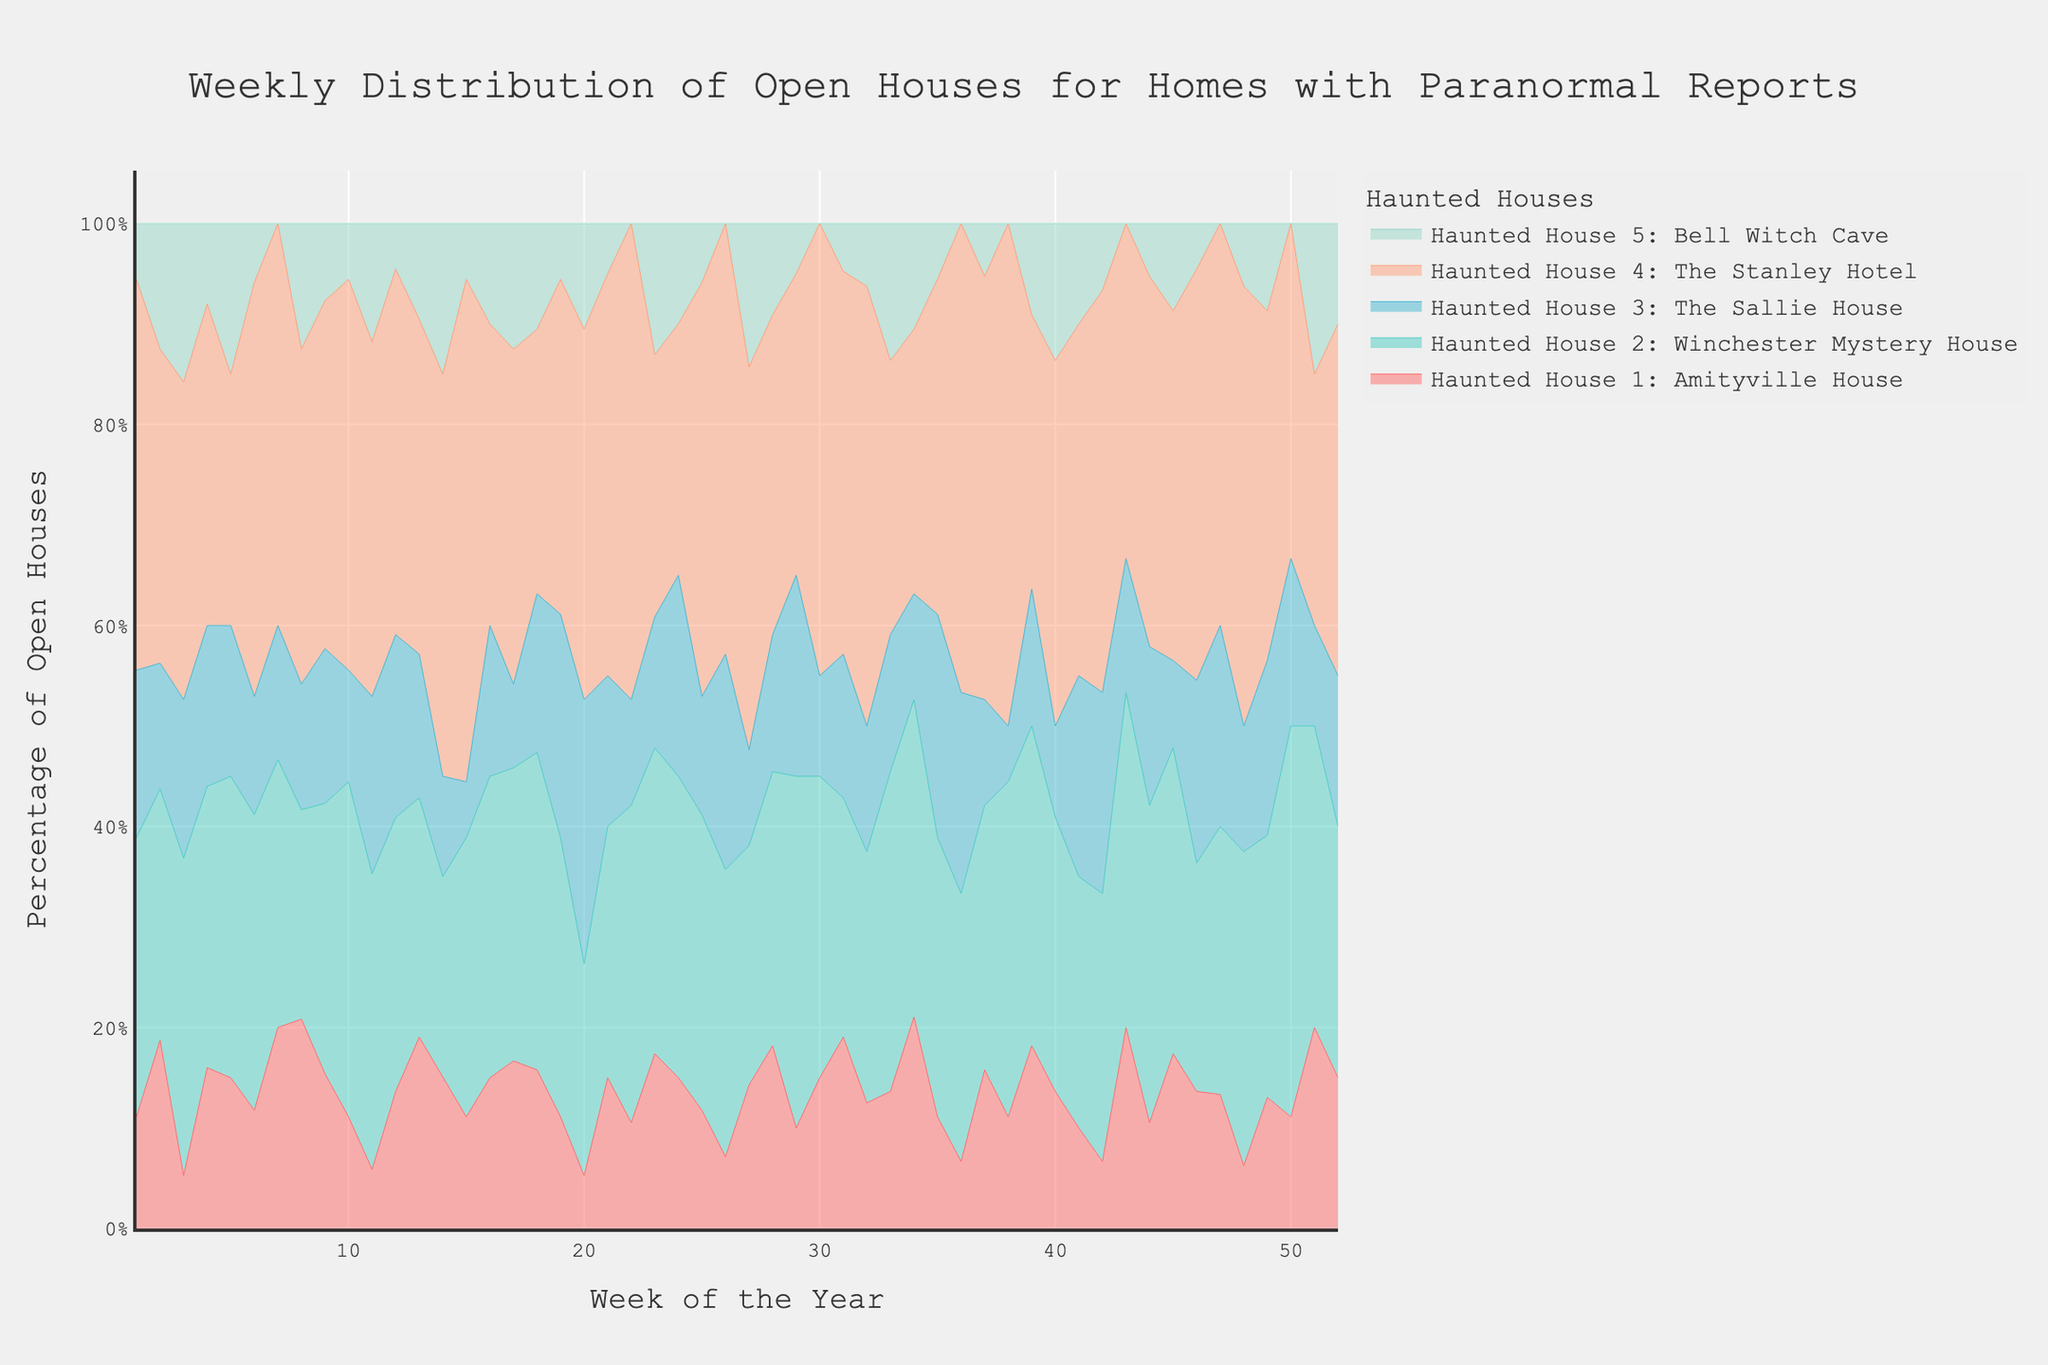What is the title of the figure? Look for the text at the top of the figure that describes the overall content.
Answer: Weekly Distribution of Open Houses for Homes with Paranormal Reports Which haunted house had the highest percentage of open houses in week 4? Identify the week 4 on the x-axis and then look for the house with the highest percentage on that week.
Answer: The Stanley Hotel How does the percentage of open houses for the Bell Witch Cave in week 10 compare to week 20? Locate the percentage for the Bell Witch Cave at week 10 and week 20 on the x-axis, and then compare them.
Answer: Week 10: 1%; Week 20: 2%; Week 20 is higher Which haunted house shows the most consistent percentage of open houses throughout the year? Look at the lines representing each house and identify which one has the smallest variations in height over time.
Answer: The Sallie House What is the sum of the percentage of open houses across all haunted houses in week 15? Add the percentage values for all haunted houses for week 15 from the figure.
Answer: Amityville House (2) + Winchester Mystery House (5) + The Sallie House (1) + The Stanley Hotel (9) + Bell Witch Cave (1) = 18% Which haunted house had the highest increase in percentage of open houses from week 1 to week 9? For each haunted house, calculate the difference in percentage from week 1 to week 9 and identify the highest increase.
Answer: The Stanley Hotel In which week does the Winchester Mystery House reach its highest percentage of open houses? Scan along the x-axis where the Winchester Mystery House has the highest peak and note the corresponding week number.
Answer: Week 9 On average, which haunted house has the lowest percentage of open houses? For each house, sum all the weekly percentages and divide by the number of weeks (52) and then compare the averages.
Answer: Bell Witch Cave What is the percentage difference between the highest and lowest open house weeks for the Amityville House? Identify the highest and lowest weeks for the Amityville House and subtract the lowest percentage from the highest percentage.
Answer: Highest: 5%; Lowest: 1%; Difference: 4% Are there any weeks where the percentage of open houses for the Stanley Hotel drops to zero? Look at the percentage values for the Stanley Hotel across all weeks on the x-axis.
Answer: No 